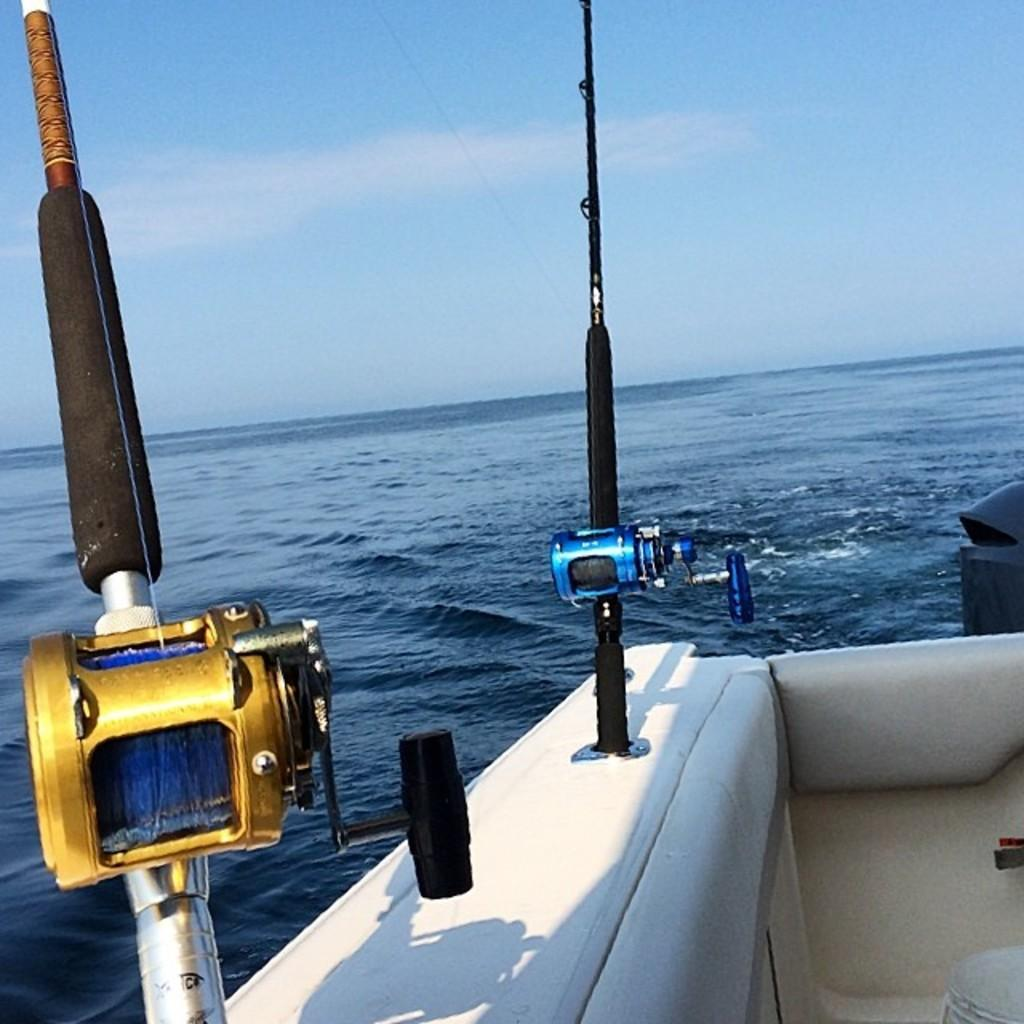What is the main subject of the image? The main subject of the image is a boat. What is the boat doing in the image? The boat is sailing on the water. What colors can be seen on the objects on the boat? The objects on the boat are black, blue, and golden. Where is the zoo located in the image? There is no zoo present in the image; it features a boat sailing on the water. What part of the brain can be seen in the image? There is no brain present in the image; it features a boat sailing on the water with black, blue, and golden objects. 